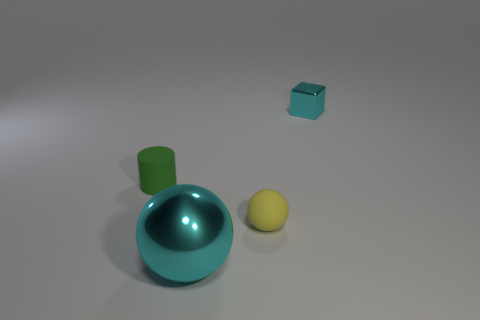The small shiny thing has what shape?
Keep it short and to the point. Cube. Is the color of the metal thing in front of the tiny metal block the same as the rubber sphere?
Make the answer very short. No. What shape is the object that is both in front of the rubber cylinder and behind the cyan sphere?
Offer a very short reply. Sphere. The big shiny object that is in front of the small green matte cylinder is what color?
Your answer should be very brief. Cyan. Is there any other thing that is the same color as the tiny ball?
Give a very brief answer. No. Does the yellow thing have the same size as the metal block?
Offer a very short reply. Yes. What is the size of the thing that is both to the right of the big metal thing and to the left of the small cyan cube?
Make the answer very short. Small. How many small yellow objects have the same material as the cube?
Offer a terse response. 0. The small metallic thing that is the same color as the large metal object is what shape?
Provide a succinct answer. Cube. What is the color of the small cylinder?
Ensure brevity in your answer.  Green. 